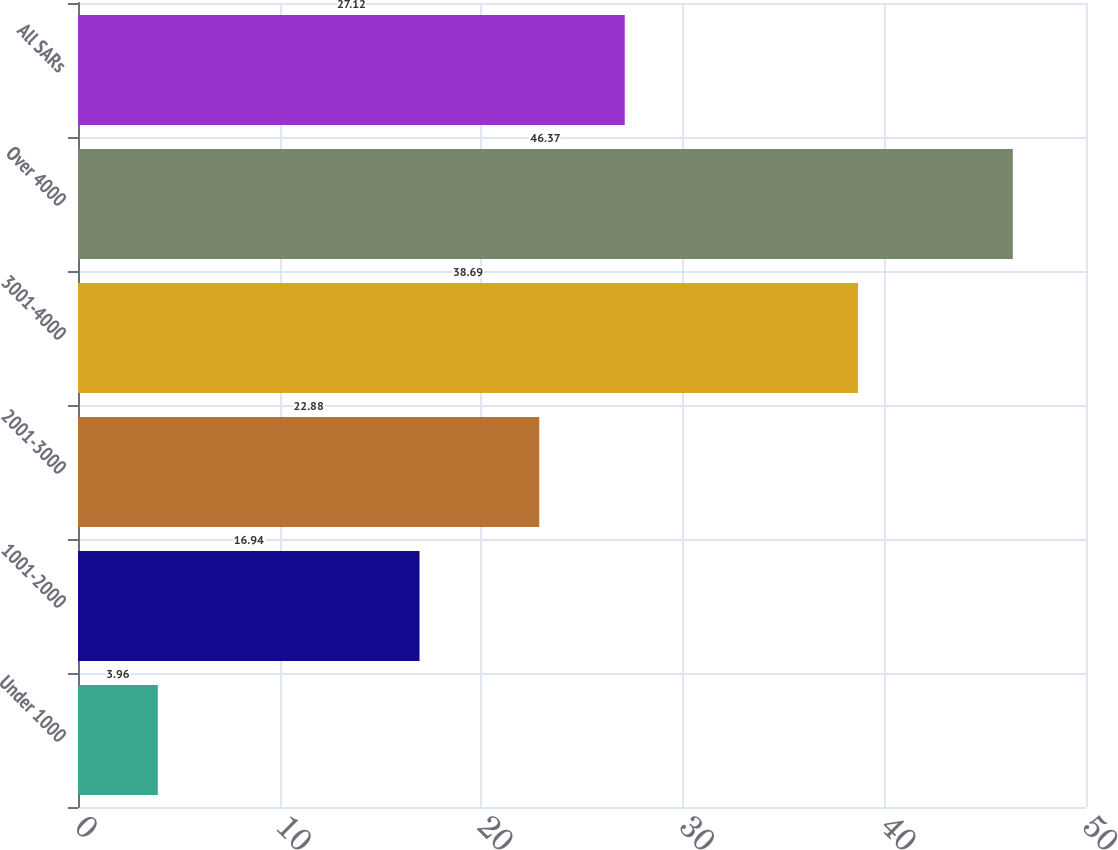Convert chart. <chart><loc_0><loc_0><loc_500><loc_500><bar_chart><fcel>Under 1000<fcel>1001-2000<fcel>2001-3000<fcel>3001-4000<fcel>Over 4000<fcel>All SARs<nl><fcel>3.96<fcel>16.94<fcel>22.88<fcel>38.69<fcel>46.37<fcel>27.12<nl></chart> 